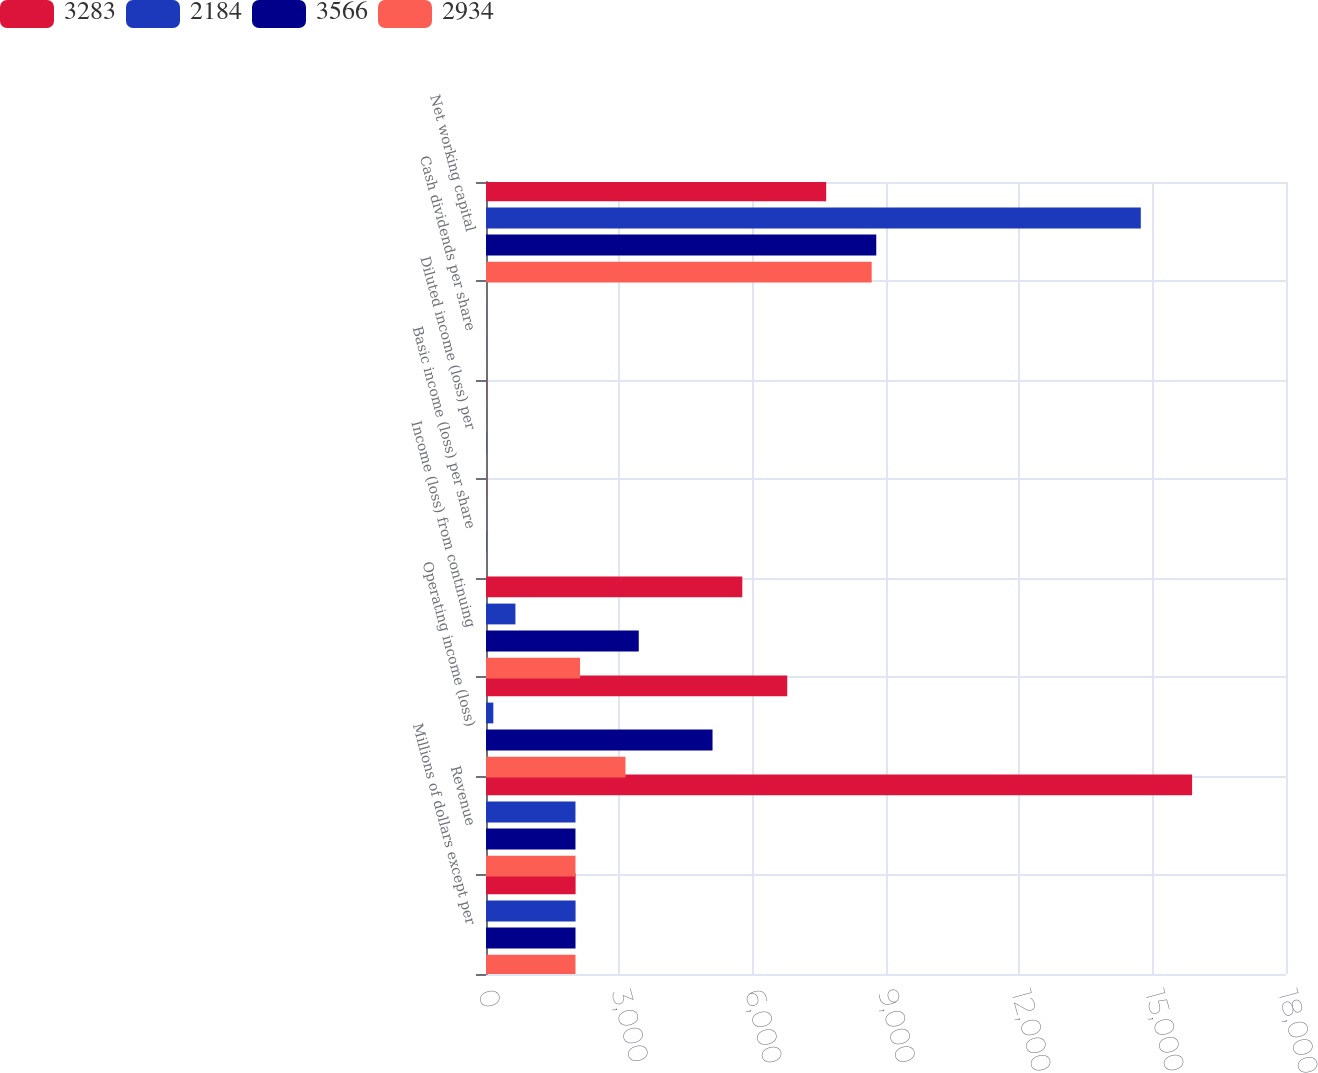Convert chart. <chart><loc_0><loc_0><loc_500><loc_500><stacked_bar_chart><ecel><fcel>Millions of dollars except per<fcel>Revenue<fcel>Operating income (loss)<fcel>Income (loss) from continuing<fcel>Basic income (loss) per share<fcel>Diluted income (loss) per<fcel>Cash dividends per share<fcel>Net working capital<nl><fcel>3283<fcel>2016<fcel>15887<fcel>6778<fcel>5767<fcel>6.69<fcel>6.69<fcel>0.72<fcel>7654<nl><fcel>2184<fcel>2015<fcel>2013<fcel>165<fcel>662<fcel>0.78<fcel>0.78<fcel>0.72<fcel>14733<nl><fcel>3566<fcel>2014<fcel>2013<fcel>5097<fcel>3437<fcel>4.05<fcel>4.03<fcel>0.63<fcel>8781<nl><fcel>2934<fcel>2013<fcel>2013<fcel>3138<fcel>2116<fcel>2.35<fcel>2.33<fcel>0.53<fcel>8678<nl></chart> 